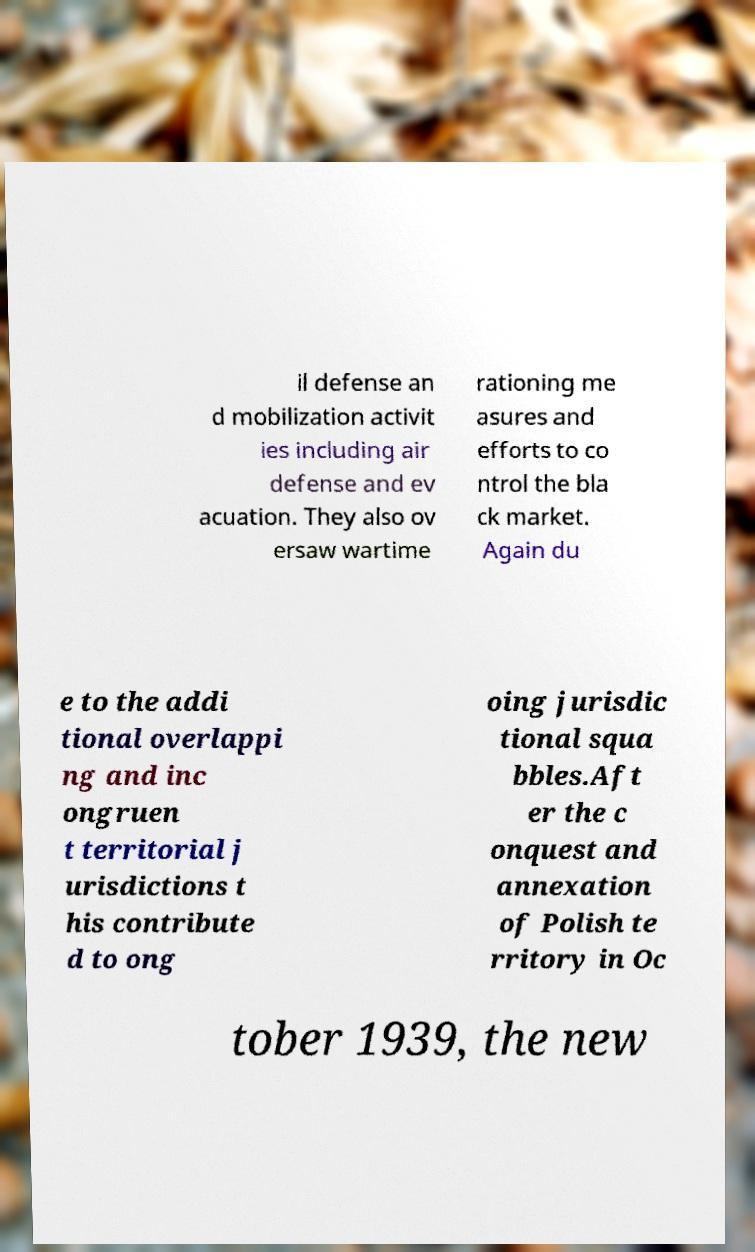Can you read and provide the text displayed in the image?This photo seems to have some interesting text. Can you extract and type it out for me? il defense an d mobilization activit ies including air defense and ev acuation. They also ov ersaw wartime rationing me asures and efforts to co ntrol the bla ck market. Again du e to the addi tional overlappi ng and inc ongruen t territorial j urisdictions t his contribute d to ong oing jurisdic tional squa bbles.Aft er the c onquest and annexation of Polish te rritory in Oc tober 1939, the new 